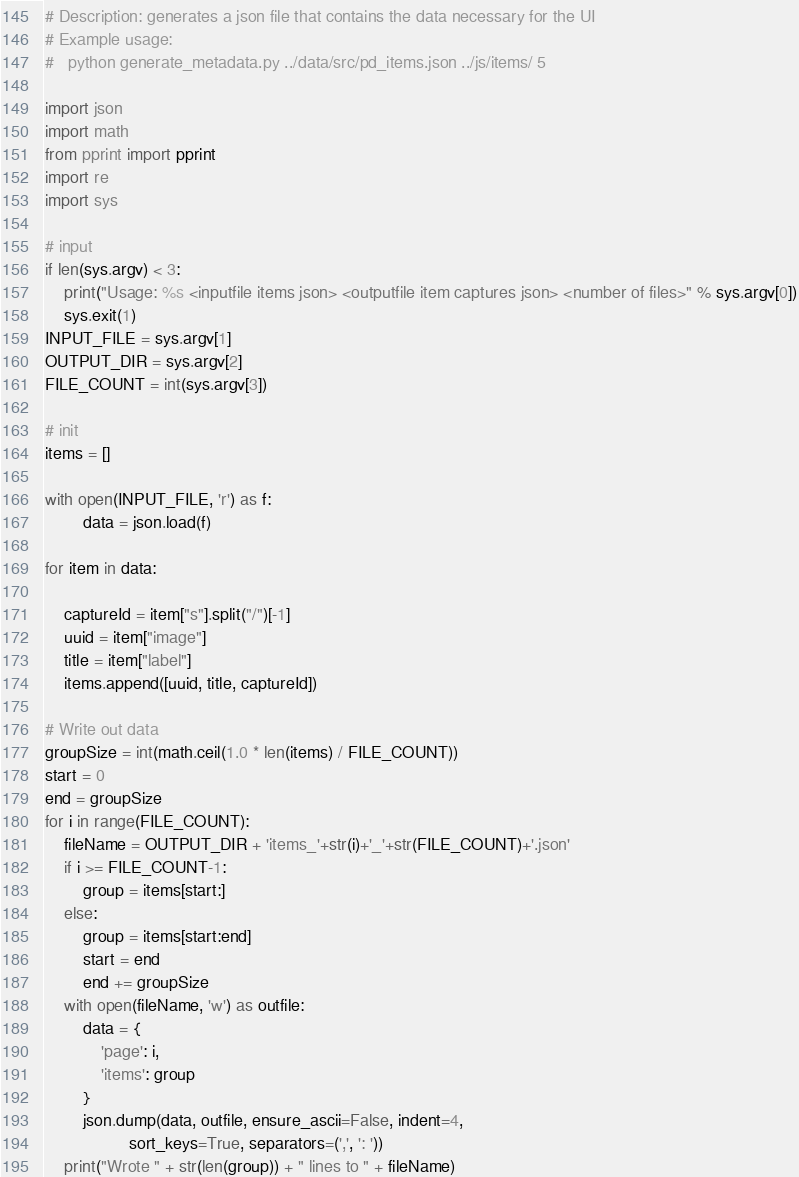<code> <loc_0><loc_0><loc_500><loc_500><_Python_># Description: generates a json file that contains the data necessary for the UI
# Example usage:
#   python generate_metadata.py ../data/src/pd_items.json ../js/items/ 5

import json
import math
from pprint import pprint
import re
import sys

# input
if len(sys.argv) < 3:
    print("Usage: %s <inputfile items json> <outputfile item captures json> <number of files>" % sys.argv[0])
    sys.exit(1)
INPUT_FILE = sys.argv[1]
OUTPUT_DIR = sys.argv[2]
FILE_COUNT = int(sys.argv[3])

# init
items = []

with open(INPUT_FILE, 'r') as f:
        data = json.load(f)

for item in data:

    captureId = item["s"].split("/")[-1]
    uuid = item["image"]
    title = item["label"]
    items.append([uuid, title, captureId])

# Write out data
groupSize = int(math.ceil(1.0 * len(items) / FILE_COUNT))
start = 0
end = groupSize
for i in range(FILE_COUNT):
    fileName = OUTPUT_DIR + 'items_'+str(i)+'_'+str(FILE_COUNT)+'.json'
    if i >= FILE_COUNT-1:
        group = items[start:]
    else:
        group = items[start:end]
        start = end
        end += groupSize
    with open(fileName, 'w') as outfile:
        data = {
            'page': i,
            'items': group
        }
        json.dump(data, outfile, ensure_ascii=False, indent=4,
                  sort_keys=True, separators=(',', ': '))
    print("Wrote " + str(len(group)) + " lines to " + fileName)
</code> 